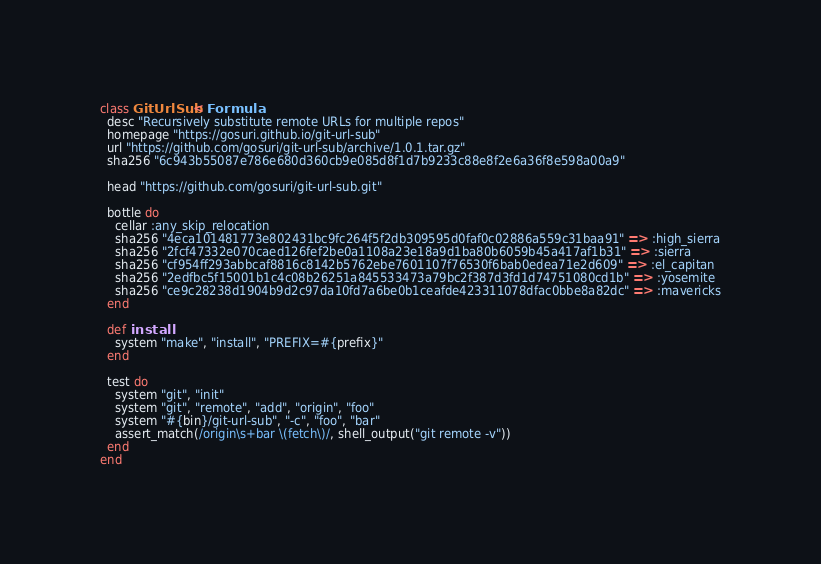<code> <loc_0><loc_0><loc_500><loc_500><_Ruby_>class GitUrlSub < Formula
  desc "Recursively substitute remote URLs for multiple repos"
  homepage "https://gosuri.github.io/git-url-sub"
  url "https://github.com/gosuri/git-url-sub/archive/1.0.1.tar.gz"
  sha256 "6c943b55087e786e680d360cb9e085d8f1d7b9233c88e8f2e6a36f8e598a00a9"

  head "https://github.com/gosuri/git-url-sub.git"

  bottle do
    cellar :any_skip_relocation
    sha256 "4eca101481773e802431bc9fc264f5f2db309595d0faf0c02886a559c31baa91" => :high_sierra
    sha256 "2fcf47332e070caed126fef2be0a1108a23e18a9d1ba80b6059b45a417af1b31" => :sierra
    sha256 "cf954ff293abbcaf8816c8142b5762ebe7601107f76530f6bab0edea71e2d609" => :el_capitan
    sha256 "2edfbc5f15001b1c4c08b26251a845533473a79bc2f387d3fd1d74751080cd1b" => :yosemite
    sha256 "ce9c28238d1904b9d2c97da10fd7a6be0b1ceafde423311078dfac0bbe8a82dc" => :mavericks
  end

  def install
    system "make", "install", "PREFIX=#{prefix}"
  end

  test do
    system "git", "init"
    system "git", "remote", "add", "origin", "foo"
    system "#{bin}/git-url-sub", "-c", "foo", "bar"
    assert_match(/origin\s+bar \(fetch\)/, shell_output("git remote -v"))
  end
end
</code> 